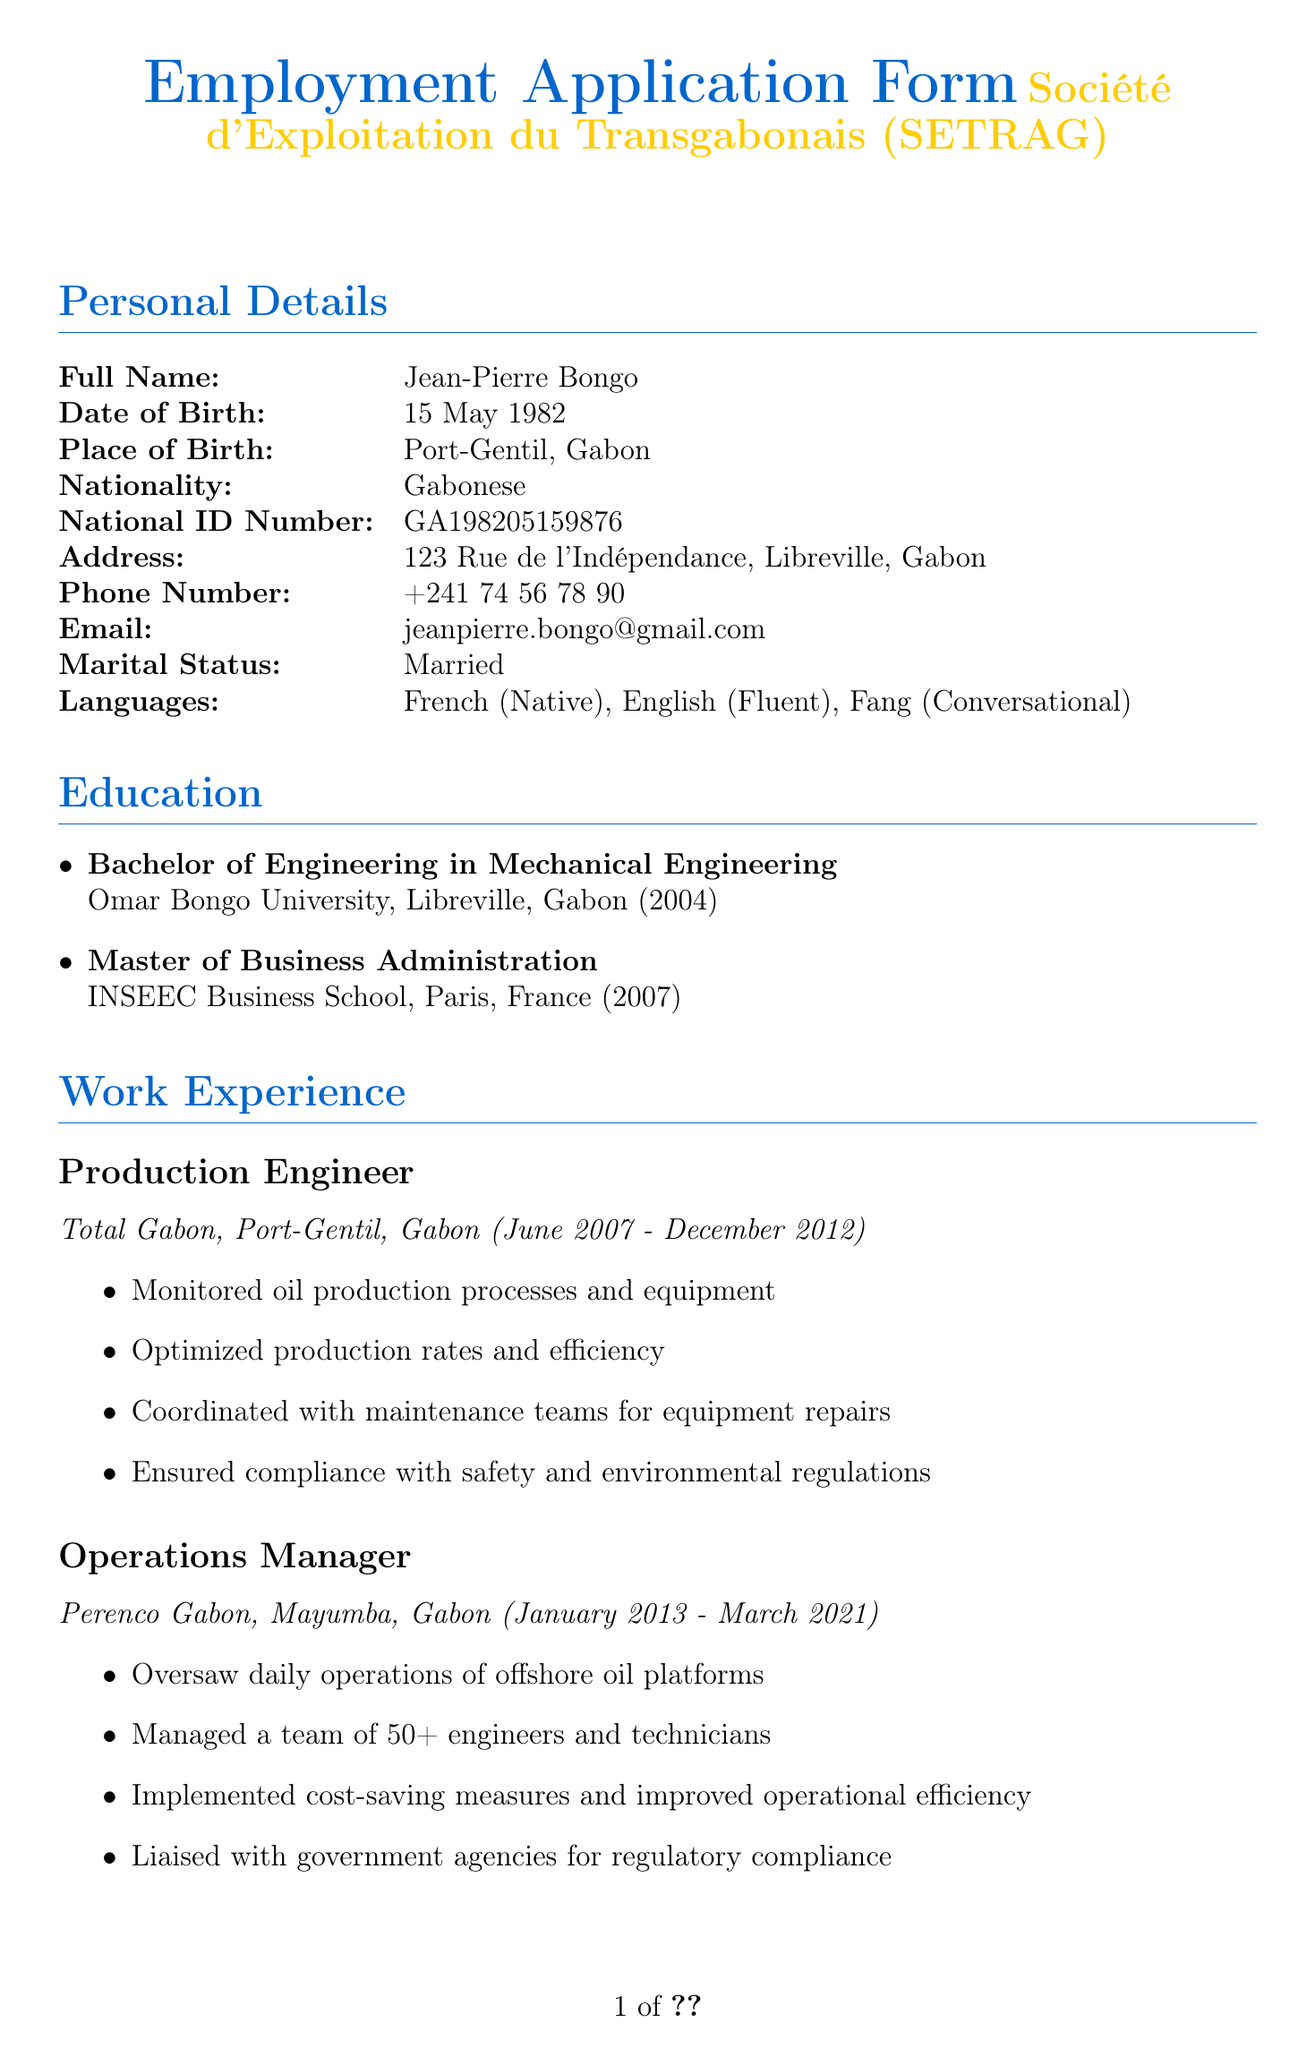What is the full name of the applicant? The full name is listed in the personal details section of the document.
Answer: Jean-Pierre Bongo What is the applicant's date of birth? The date of birth is provided clearly in the personal details section.
Answer: 15 May 1982 Which university did the applicant attend for their Bachelor of Engineering? The institution for the bachelor's degree is mentioned in the education section of the document.
Answer: Omar Bongo University What position is the applicant applying for? The position applied for is specifically mentioned in the additional information section.
Answer: Logistics Manager What is the desired salary of the applicant? The desired salary is explicitly stated in the document under the additional information section.
Answer: 15,000,000 Central African CFA francs per annum How many years did the applicant work at Total Gabon? The time span mentioned in the work experience section helps to calculate the duration of employment.
Answer: 5 years Why did the applicant leave the oil sector? The reason for leaving is stated in the additional information section of the application.
Answer: Seeking new challenges in a different industry and contributing to Gabon's economic diversification Which languages does the applicant speak? The languages spoken by the applicant are listed in the personal details section.
Answer: French (Native), English (Fluent), Fang (Conversational) Who is one of the references provided by the applicant? A reference is mentioned in the references section and can be identified by name.
Answer: Dr. Marie Nguema 